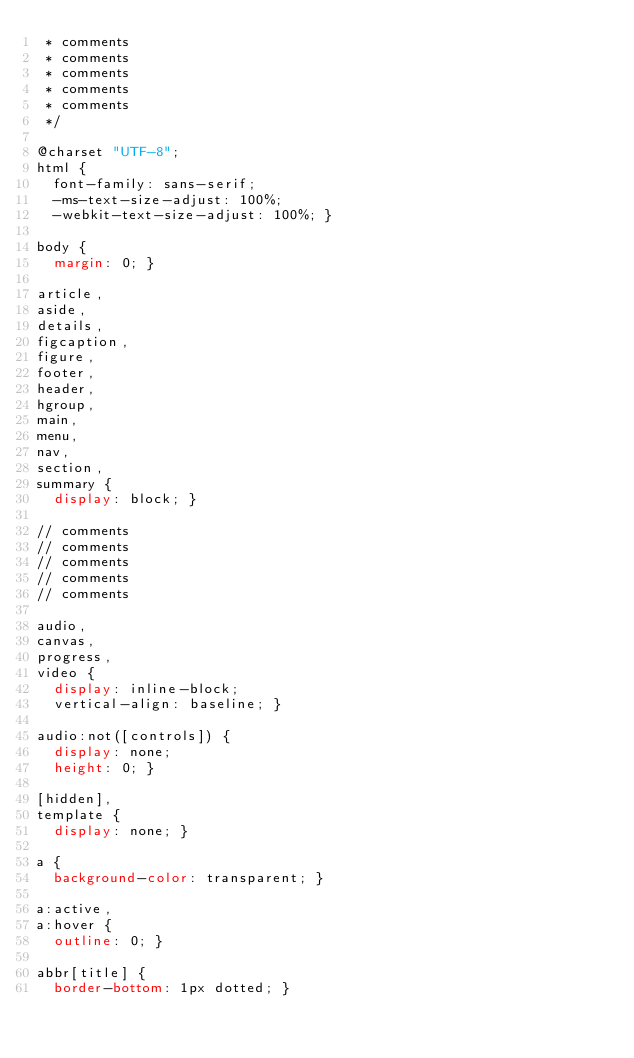Convert code to text. <code><loc_0><loc_0><loc_500><loc_500><_CSS_> * comments
 * comments
 * comments
 * comments
 * comments
 */

@charset "UTF-8";
html {
  font-family: sans-serif;
  -ms-text-size-adjust: 100%;
  -webkit-text-size-adjust: 100%; }

body {
  margin: 0; }

article,
aside,
details,
figcaption,
figure,
footer,
header,
hgroup,
main,
menu,
nav,
section,
summary {
  display: block; }

// comments
// comments
// comments
// comments
// comments

audio,
canvas,
progress,
video {
  display: inline-block;
  vertical-align: baseline; }

audio:not([controls]) {
  display: none;
  height: 0; }

[hidden],
template {
  display: none; }

a {
  background-color: transparent; }

a:active,
a:hover {
  outline: 0; }

abbr[title] {
  border-bottom: 1px dotted; }
</code> 